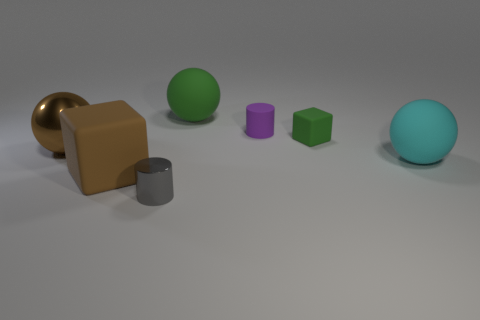Add 1 gray cylinders. How many objects exist? 8 Subtract all blocks. How many objects are left? 5 Add 6 small matte balls. How many small matte balls exist? 6 Subtract 1 purple cylinders. How many objects are left? 6 Subtract all big cyan balls. Subtract all cyan objects. How many objects are left? 5 Add 7 small gray shiny things. How many small gray shiny things are left? 8 